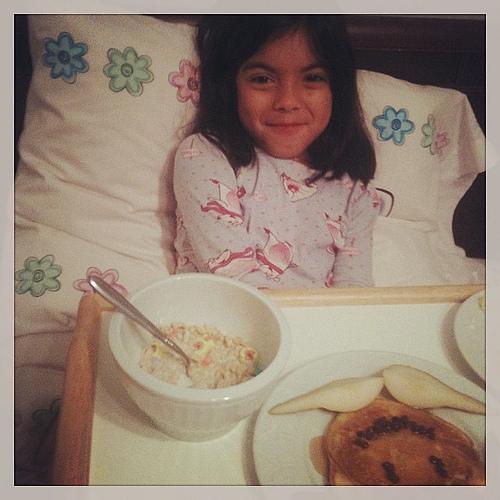How many people in the picture?
Give a very brief answer. 1. How many bowls of cereal are there?
Give a very brief answer. 1. 